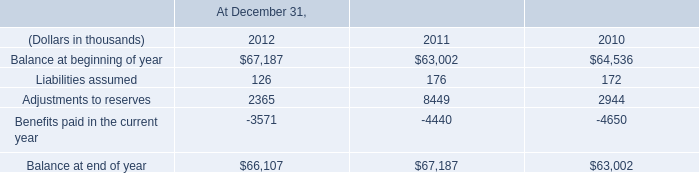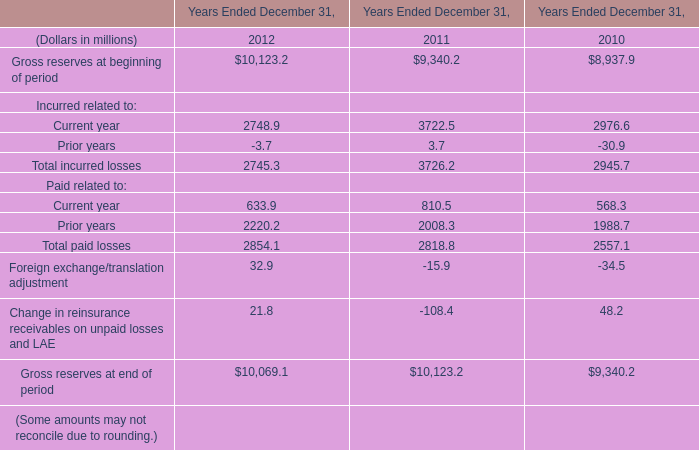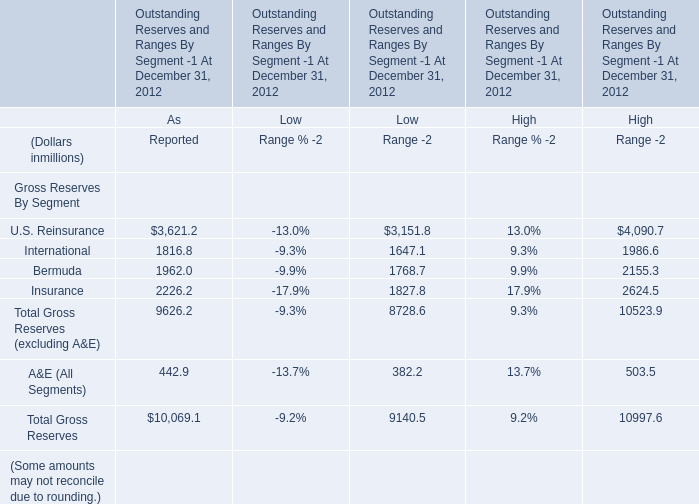at december 31 , 2012 , what was the ratio of the case reserves reported by ceding to the additional case reserves established by the company 
Computations: (138449 / 90637)
Answer: 1.52751. 